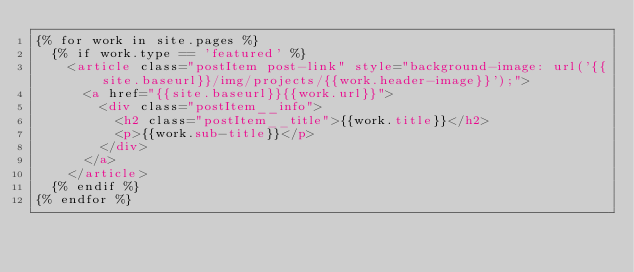<code> <loc_0><loc_0><loc_500><loc_500><_HTML_>{% for work in site.pages %}
  {% if work.type == 'featured' %}
    <article class="postItem post-link" style="background-image: url('{{site.baseurl}}/img/projects/{{work.header-image}}');">
      <a href="{{site.baseurl}}{{work.url}}">
        <div class="postItem__info">
          <h2 class="postItem__title">{{work.title}}</h2>
          <p>{{work.sub-title}}</p>
        </div>
      </a>
    </article>
  {% endif %}
{% endfor %}
</code> 